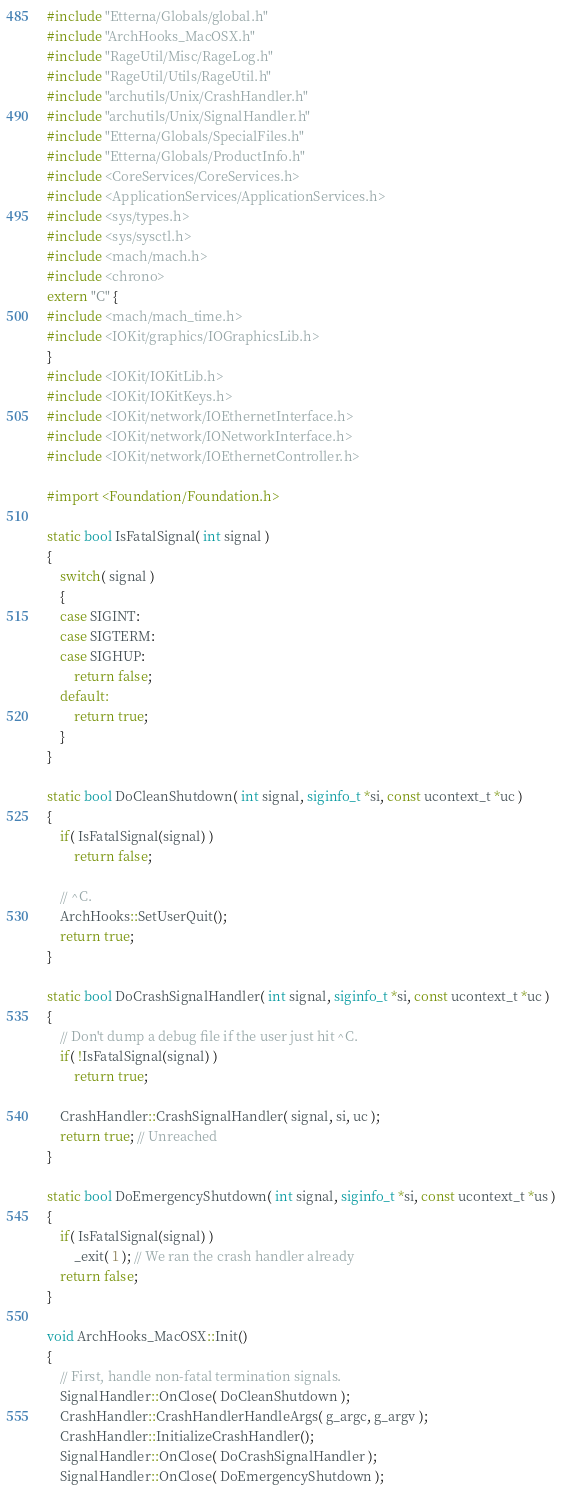Convert code to text. <code><loc_0><loc_0><loc_500><loc_500><_ObjectiveC_>#include "Etterna/Globals/global.h"
#include "ArchHooks_MacOSX.h"
#include "RageUtil/Misc/RageLog.h"
#include "RageUtil/Utils/RageUtil.h"
#include "archutils/Unix/CrashHandler.h"
#include "archutils/Unix/SignalHandler.h"
#include "Etterna/Globals/SpecialFiles.h"
#include "Etterna/Globals/ProductInfo.h"
#include <CoreServices/CoreServices.h>
#include <ApplicationServices/ApplicationServices.h>
#include <sys/types.h>
#include <sys/sysctl.h>
#include <mach/mach.h>
#include <chrono>
extern "C" {
#include <mach/mach_time.h>
#include <IOKit/graphics/IOGraphicsLib.h>
}
#include <IOKit/IOKitLib.h>
#include <IOKit/IOKitKeys.h>
#include <IOKit/network/IOEthernetInterface.h>
#include <IOKit/network/IONetworkInterface.h>
#include <IOKit/network/IOEthernetController.h>

#import <Foundation/Foundation.h>

static bool IsFatalSignal( int signal )
{
	switch( signal )
	{
	case SIGINT:
	case SIGTERM:
	case SIGHUP:
		return false;
	default:
		return true;
	}
}

static bool DoCleanShutdown( int signal, siginfo_t *si, const ucontext_t *uc )
{
	if( IsFatalSignal(signal) )
		return false;

	// ^C.
	ArchHooks::SetUserQuit();
	return true;
}

static bool DoCrashSignalHandler( int signal, siginfo_t *si, const ucontext_t *uc )
{
	// Don't dump a debug file if the user just hit ^C.
	if( !IsFatalSignal(signal) )
		return true;

	CrashHandler::CrashSignalHandler( signal, si, uc );
	return true; // Unreached
}

static bool DoEmergencyShutdown( int signal, siginfo_t *si, const ucontext_t *us )
{
	if( IsFatalSignal(signal) )
		_exit( 1 ); // We ran the crash handler already
	return false;
}

void ArchHooks_MacOSX::Init()
{
	// First, handle non-fatal termination signals.
	SignalHandler::OnClose( DoCleanShutdown );
	CrashHandler::CrashHandlerHandleArgs( g_argc, g_argv );
	CrashHandler::InitializeCrashHandler();
	SignalHandler::OnClose( DoCrashSignalHandler );
	SignalHandler::OnClose( DoEmergencyShutdown );
</code> 